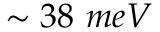<formula> <loc_0><loc_0><loc_500><loc_500>\sim 3 8 \ m e V</formula> 